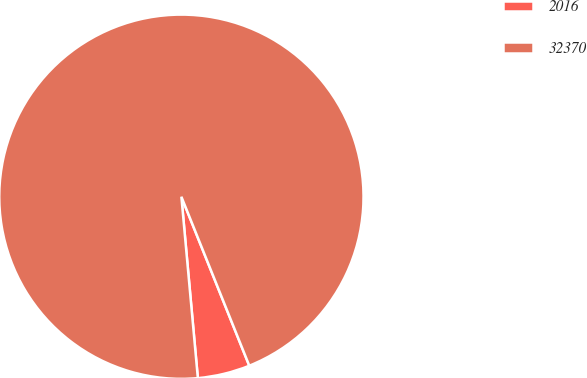<chart> <loc_0><loc_0><loc_500><loc_500><pie_chart><fcel>2016<fcel>32370<nl><fcel>4.64%<fcel>95.36%<nl></chart> 